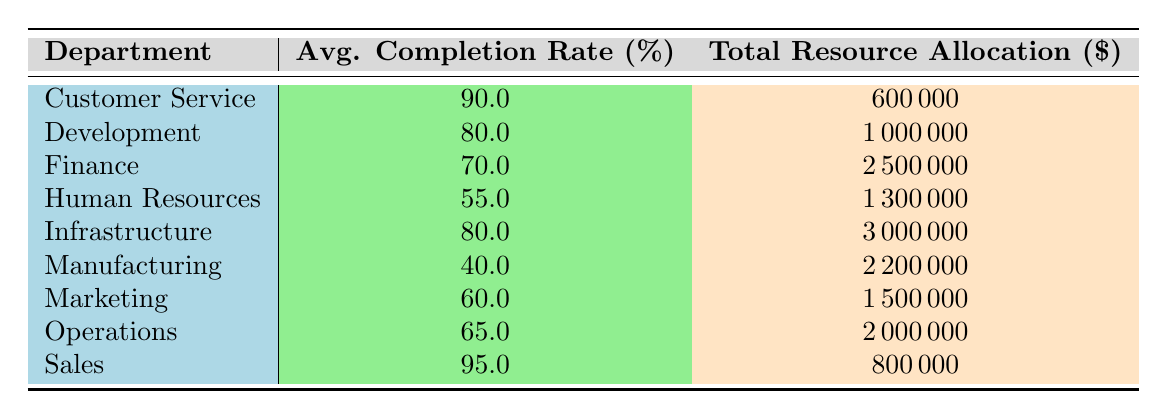What's the average completion rate for the Infrastructure department? The completion rates for the projects under the Infrastructure department are 85% for Cloud Migration and 75% for Cybersecurity Enhancement. The average is calculated as (85 + 75) / 2 = 80%.
Answer: 80 Which department has the highest total resource allocation? From the table, the Finance department has a total resource allocation of $2,500,000, which is higher than any other department's allocation, confirming it has the highest total resource allocation.
Answer: Finance Is the completion rate for the Sales department greater than 90%? The completion rate for the Sales department is 95%, which is indeed greater than 90%.
Answer: Yes What is the total resource allocation for departments with a completion rate above 80%? The departments with a completion rate above 80% are Customer Service (600,000), Development (1,000,000), Infrastructure (3,000,000), and Sales (800,000). Summing these amounts gives 600,000 + 1,000,000 + 3,000,000 + 800,000 = 5,400,000.
Answer: 5,400,000 Does the Marketing department have a completion rate lower than 70%? The completion rate for the Marketing department is 60%, which is lower than 70%.
Answer: Yes What is the average completion rate for all departments listed in the table? The completion rates for all departments are 90, 80, 70, 55, 80, 40, 60, 65, and 95. The average is calculated by summing these rates and dividing by the number of departments: (90 + 80 + 70 + 55 + 80 + 40 + 60 + 65 + 95) / 9 = 69.44, rounded to two decimal points is 69.44%.
Answer: 69.44 Which department has the lowest completion rate? The department with the lowest completion rate is Manufacturing, which has a completion rate of 40%.
Answer: Manufacturing What is the difference in total resource allocation between the Finance and Human Resources departments? The Finance department has a resource allocation of $2,500,000, while Human Resources has $1,300,000. The difference is calculated as 2,500,000 - 1,300,000 = 1,200,000.
Answer: 1,200,000 What is the sum of completion rates for departments with a priority of "High"? The departments with "High" priority are Infrastructure (completion rate 80), Development (completion rate 80), Supply Chain Optimization (completion rate 65), and Cloud Migration (completion rate 85). The sum is 80 + 80 + 65 + 85 = 310.
Answer: 310 